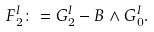Convert formula to latex. <formula><loc_0><loc_0><loc_500><loc_500>F _ { 2 } ^ { I } \colon = G _ { 2 } ^ { I } - B \wedge G _ { 0 } ^ { I } .</formula> 